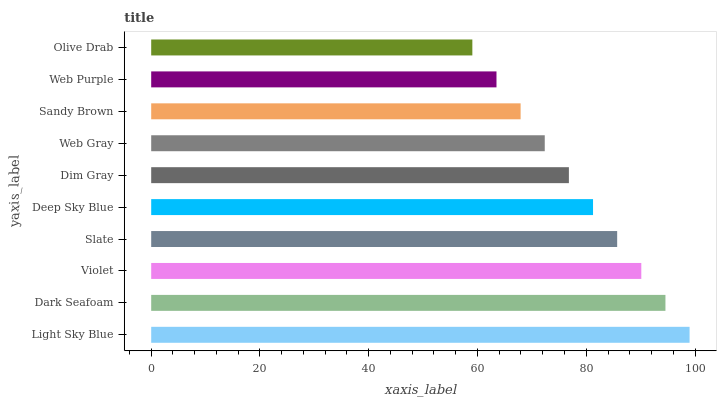Is Olive Drab the minimum?
Answer yes or no. Yes. Is Light Sky Blue the maximum?
Answer yes or no. Yes. Is Dark Seafoam the minimum?
Answer yes or no. No. Is Dark Seafoam the maximum?
Answer yes or no. No. Is Light Sky Blue greater than Dark Seafoam?
Answer yes or no. Yes. Is Dark Seafoam less than Light Sky Blue?
Answer yes or no. Yes. Is Dark Seafoam greater than Light Sky Blue?
Answer yes or no. No. Is Light Sky Blue less than Dark Seafoam?
Answer yes or no. No. Is Deep Sky Blue the high median?
Answer yes or no. Yes. Is Dim Gray the low median?
Answer yes or no. Yes. Is Web Gray the high median?
Answer yes or no. No. Is Sandy Brown the low median?
Answer yes or no. No. 